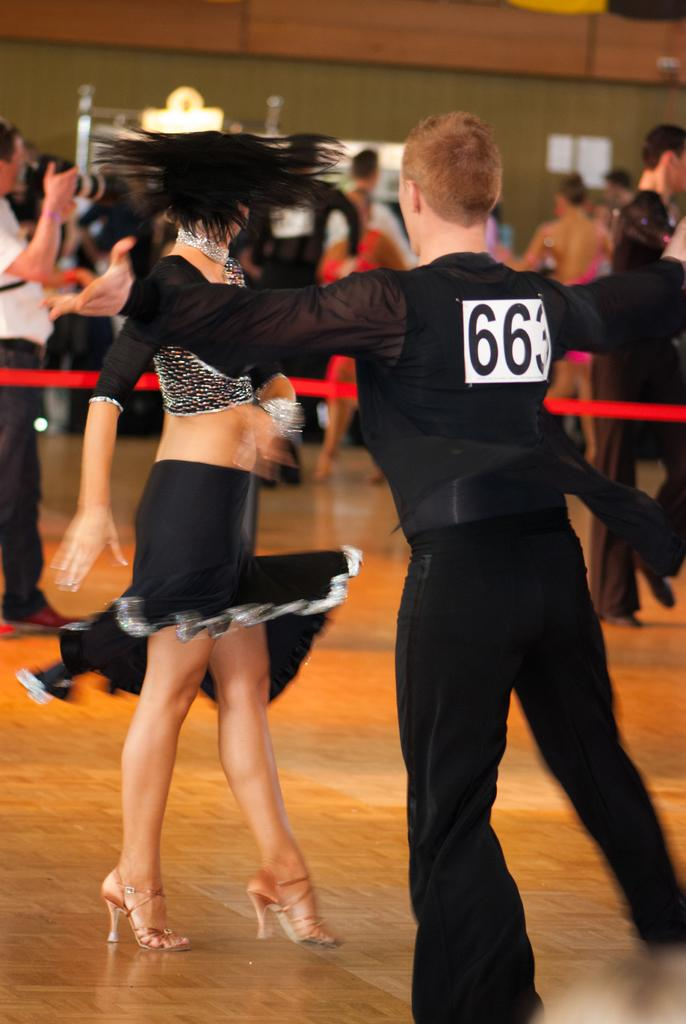Who are the main subjects in the image? There is a lady and a guy in the image. What are the lady and the guy doing in the image? The lady and the guy are dancing in the image. Are there any other people present in the image besides the lady and the guy? Yes, there are other people present in the image. What is the profit made by the lady and the guy while dancing in the image? There is no mention of profit in the image, as it focuses on the subjects and their actions. 